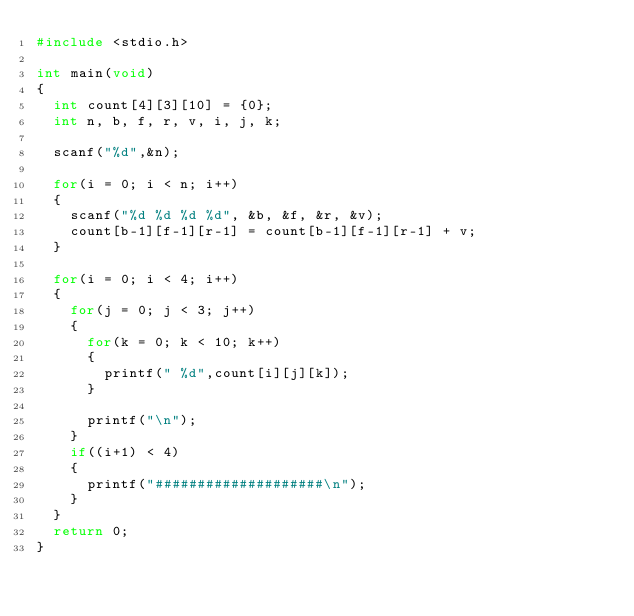Convert code to text. <code><loc_0><loc_0><loc_500><loc_500><_C_>#include <stdio.h> 

int main(void)
{
	int count[4][3][10] = {0};
	int n, b, f, r, v, i, j, k;

	scanf("%d",&n);

	for(i = 0; i < n; i++)
	{
		scanf("%d %d %d %d", &b, &f, &r, &v);
		count[b-1][f-1][r-1] = count[b-1][f-1][r-1] + v;
	}

	for(i = 0; i < 4; i++)
	{
		for(j = 0; j < 3; j++)
		{
			for(k = 0; k < 10; k++)
			{
				printf(" %d",count[i][j][k]);
			}

			printf("\n");
		}
		if((i+1) < 4)
		{
			printf("####################\n");
		}
	}
	return 0;
}</code> 